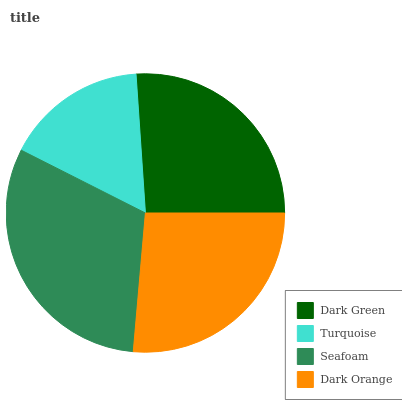Is Turquoise the minimum?
Answer yes or no. Yes. Is Seafoam the maximum?
Answer yes or no. Yes. Is Seafoam the minimum?
Answer yes or no. No. Is Turquoise the maximum?
Answer yes or no. No. Is Seafoam greater than Turquoise?
Answer yes or no. Yes. Is Turquoise less than Seafoam?
Answer yes or no. Yes. Is Turquoise greater than Seafoam?
Answer yes or no. No. Is Seafoam less than Turquoise?
Answer yes or no. No. Is Dark Orange the high median?
Answer yes or no. Yes. Is Dark Green the low median?
Answer yes or no. Yes. Is Turquoise the high median?
Answer yes or no. No. Is Seafoam the low median?
Answer yes or no. No. 